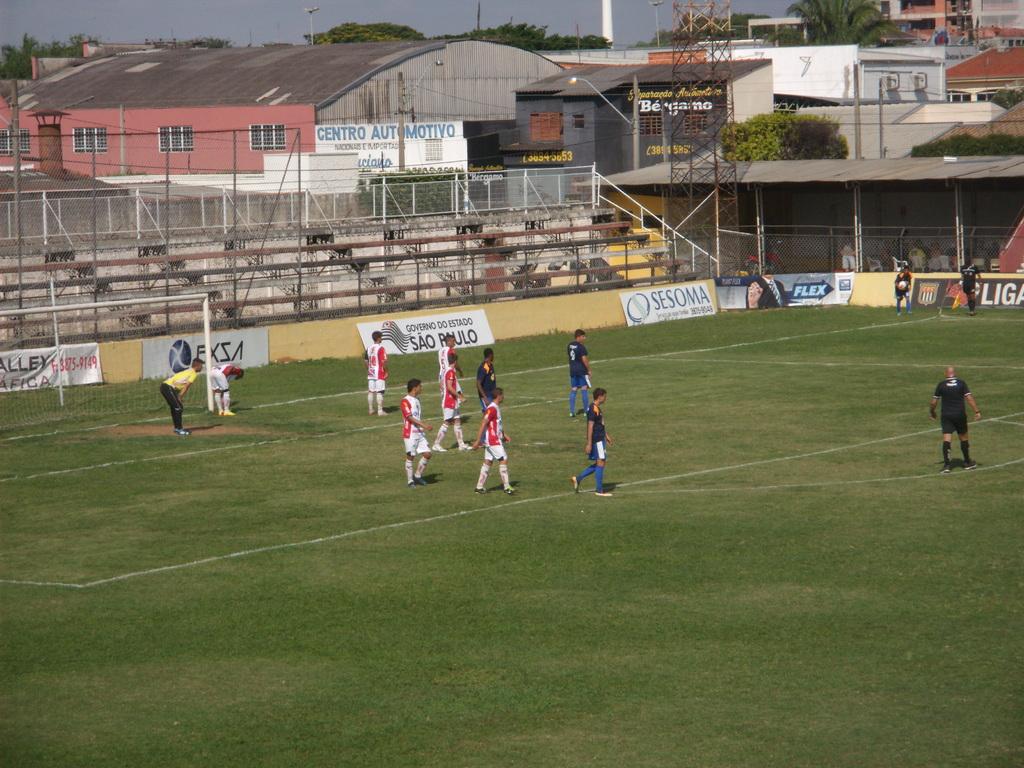What is the name of the sponsor in the corner on the left?
Your answer should be compact. Sesoma. What word is written in blue on the banner near the corner?
Make the answer very short. Flex. 